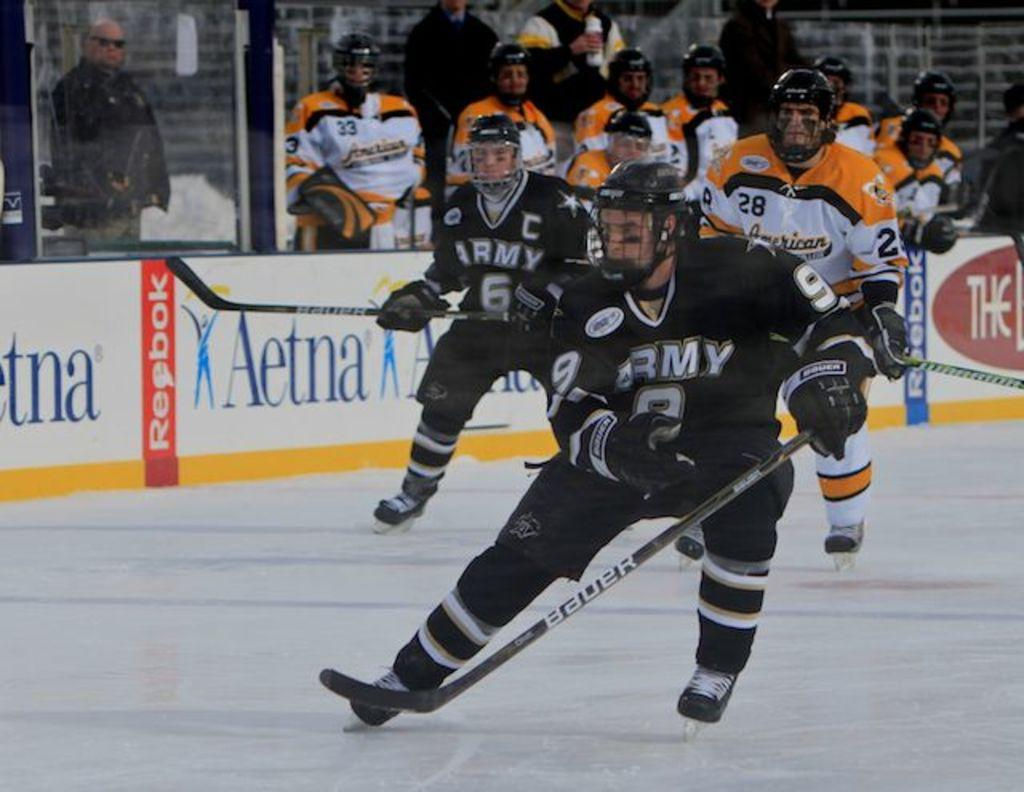<image>
Relay a brief, clear account of the picture shown. Hockey players skating on ice court sponsored by Aetna 